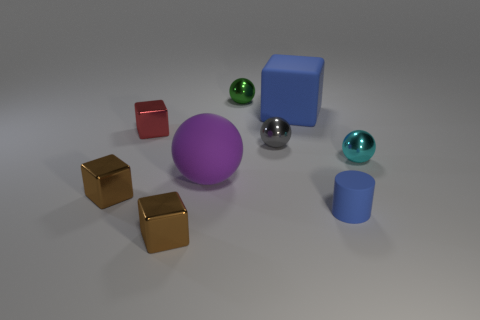Can you describe the arrangement and colors of the objects on the table? Certainly! There are eight objects resting on a flat surface. From left to right, the following objects are visible: three yellow cubes, a singular red cube, a large purple sphere, a small silver sphere, a teal sphere, a large blue cube, and a small blue cylinder. The arrangement appears methodical, with ample space between each object, creating an orderly scene. 